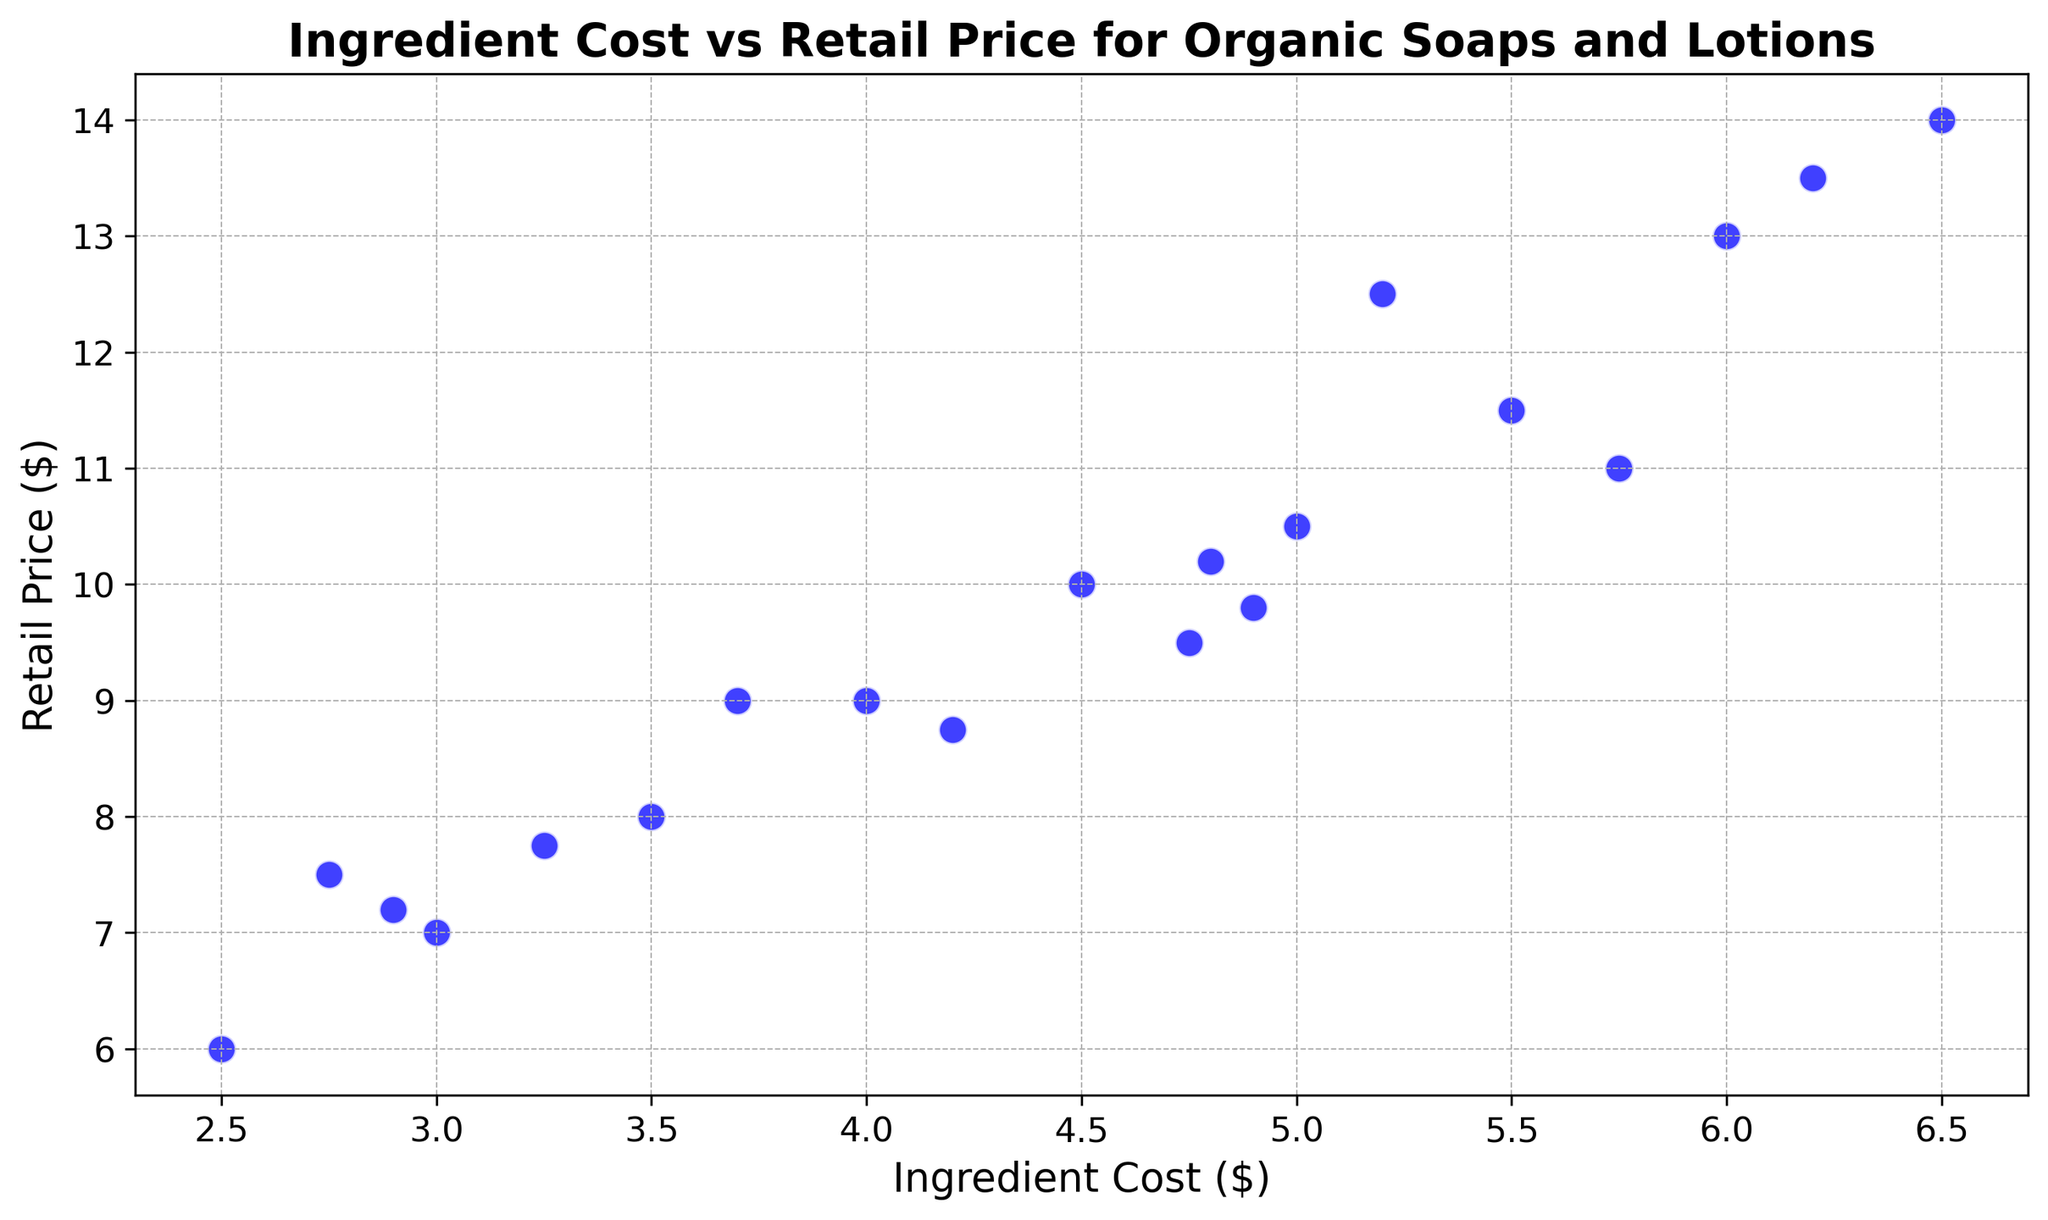What is the highest retail price for organic soaps and lotions? To find the highest retail price, observe the scatter plot and look for the data point with the maximum y-value (Retail Price).
Answer: $14.00 Which product has the lowest ingredient cost? Identify the data point with the smallest x-value (Ingredient Cost) on the scatter plot.
Answer: $2.50 What is the average retail price of the products? Sum all the y-values (Retail Price) and divide by the total number of data points: (8 + 9 + 7.5 + 12.5 + 10 + 7 + 9.5 + 13 + 11 + 6 + 10.5 + 7.75 + 14 + 8.75 + 11.5 + 9 + 9.8 + 13.5 + 7.2 + 10.2) / 20 = 10.065
Answer: $10.06 Is there a positive correlation between ingredient cost and retail price? By observing the scatter plot, if y-values (Retail Price) generally increase with increasing x-values (Ingredient Cost), it indicates a positive correlation.
Answer: Yes Which product with an ingredient cost greater than $5 has the lowest retail price? Filter the scatter plot to consider only points with x-values (Ingredient Cost) greater than $5 and then identify the point with the lowest y-value (Retail Price).
Answer: $11.00 How many products have a retail price of at least $10? Count the number of data points with y-values (Retail Price) of $10 or higher.
Answer: 10 What is the difference between the highest and lowest retail prices? Subtract the smallest y-value (Retail Price) from the largest y-value. (14 - 6) = 8
Answer: $8.00 Do any products have equal ingredient cost but different retail prices? Look for x-values (Ingredient Cost) that are the same while having different y-values (Retail Price).
Answer: Yes Comparing products with an ingredient cost of $4.00 and $5.00, which has a higher retail price? Find the y-values (Retail Price) for x-values of $4.00 and $5.00, and compare them.
Answer: $5.00 What's the average ingredient cost of products with a retail price above $10? Sum the x-values (Ingredient Cost) for the points with y-values (Retail Price) greater than $10 and divide by the number of such points: (5.2 + 6 + 5.75 + 6.5 + 5.5 + 6.2)/6 = 5.7
Answer: $5.70 